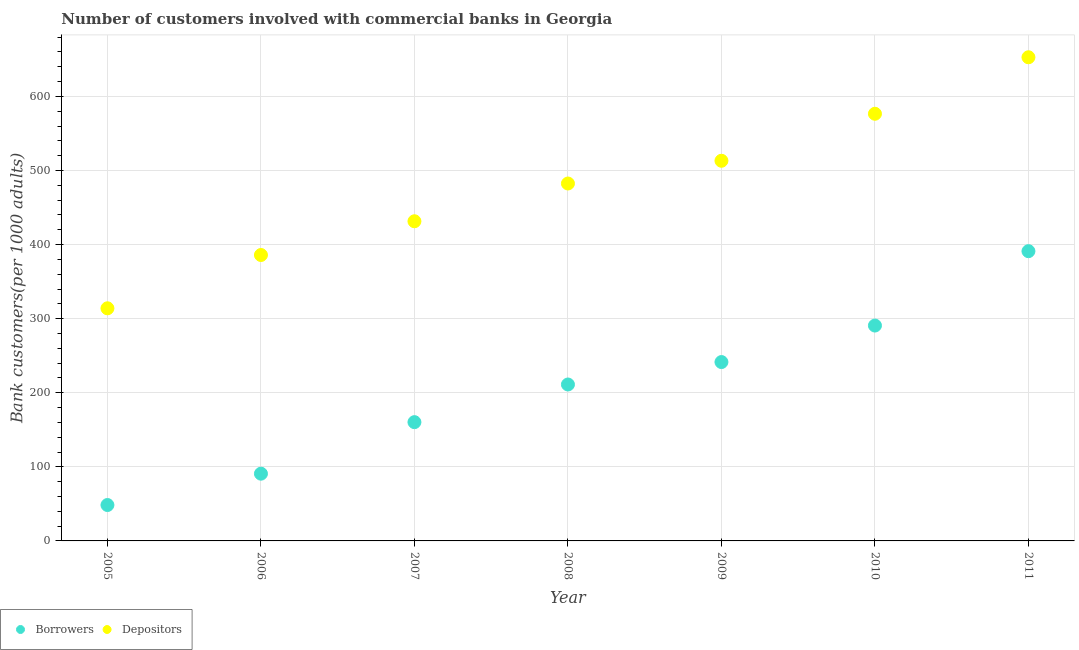How many different coloured dotlines are there?
Offer a terse response. 2. Is the number of dotlines equal to the number of legend labels?
Your answer should be compact. Yes. What is the number of borrowers in 2006?
Provide a succinct answer. 90.78. Across all years, what is the maximum number of borrowers?
Provide a succinct answer. 391.13. Across all years, what is the minimum number of borrowers?
Your answer should be very brief. 48.46. What is the total number of depositors in the graph?
Your answer should be compact. 3356.62. What is the difference between the number of depositors in 2006 and that in 2011?
Offer a terse response. -266.92. What is the difference between the number of borrowers in 2010 and the number of depositors in 2008?
Give a very brief answer. -191.75. What is the average number of borrowers per year?
Offer a very short reply. 204.86. In the year 2010, what is the difference between the number of borrowers and number of depositors?
Make the answer very short. -285.89. In how many years, is the number of borrowers greater than 520?
Make the answer very short. 0. What is the ratio of the number of borrowers in 2005 to that in 2007?
Make the answer very short. 0.3. Is the number of depositors in 2005 less than that in 2008?
Give a very brief answer. Yes. What is the difference between the highest and the second highest number of borrowers?
Keep it short and to the point. 100.4. What is the difference between the highest and the lowest number of borrowers?
Ensure brevity in your answer.  342.66. In how many years, is the number of borrowers greater than the average number of borrowers taken over all years?
Offer a very short reply. 4. Is the number of depositors strictly greater than the number of borrowers over the years?
Your answer should be compact. Yes. Is the number of depositors strictly less than the number of borrowers over the years?
Your response must be concise. No. What is the difference between two consecutive major ticks on the Y-axis?
Your response must be concise. 100. Does the graph contain any zero values?
Give a very brief answer. No. Does the graph contain grids?
Your answer should be very brief. Yes. Where does the legend appear in the graph?
Offer a terse response. Bottom left. What is the title of the graph?
Your answer should be very brief. Number of customers involved with commercial banks in Georgia. What is the label or title of the Y-axis?
Make the answer very short. Bank customers(per 1000 adults). What is the Bank customers(per 1000 adults) in Borrowers in 2005?
Your response must be concise. 48.46. What is the Bank customers(per 1000 adults) in Depositors in 2005?
Ensure brevity in your answer.  314.01. What is the Bank customers(per 1000 adults) of Borrowers in 2006?
Your response must be concise. 90.78. What is the Bank customers(per 1000 adults) of Depositors in 2006?
Offer a terse response. 385.96. What is the Bank customers(per 1000 adults) in Borrowers in 2007?
Ensure brevity in your answer.  160.33. What is the Bank customers(per 1000 adults) in Depositors in 2007?
Offer a very short reply. 431.51. What is the Bank customers(per 1000 adults) in Borrowers in 2008?
Make the answer very short. 211.16. What is the Bank customers(per 1000 adults) of Depositors in 2008?
Offer a terse response. 482.47. What is the Bank customers(per 1000 adults) of Borrowers in 2009?
Your answer should be very brief. 241.45. What is the Bank customers(per 1000 adults) of Depositors in 2009?
Keep it short and to the point. 513.17. What is the Bank customers(per 1000 adults) of Borrowers in 2010?
Your answer should be very brief. 290.72. What is the Bank customers(per 1000 adults) in Depositors in 2010?
Make the answer very short. 576.61. What is the Bank customers(per 1000 adults) of Borrowers in 2011?
Provide a short and direct response. 391.13. What is the Bank customers(per 1000 adults) of Depositors in 2011?
Provide a succinct answer. 652.89. Across all years, what is the maximum Bank customers(per 1000 adults) of Borrowers?
Provide a short and direct response. 391.13. Across all years, what is the maximum Bank customers(per 1000 adults) of Depositors?
Provide a succinct answer. 652.89. Across all years, what is the minimum Bank customers(per 1000 adults) of Borrowers?
Your response must be concise. 48.46. Across all years, what is the minimum Bank customers(per 1000 adults) of Depositors?
Provide a succinct answer. 314.01. What is the total Bank customers(per 1000 adults) of Borrowers in the graph?
Offer a very short reply. 1434.03. What is the total Bank customers(per 1000 adults) of Depositors in the graph?
Your answer should be compact. 3356.62. What is the difference between the Bank customers(per 1000 adults) in Borrowers in 2005 and that in 2006?
Give a very brief answer. -42.32. What is the difference between the Bank customers(per 1000 adults) in Depositors in 2005 and that in 2006?
Keep it short and to the point. -71.95. What is the difference between the Bank customers(per 1000 adults) in Borrowers in 2005 and that in 2007?
Your answer should be compact. -111.87. What is the difference between the Bank customers(per 1000 adults) in Depositors in 2005 and that in 2007?
Offer a terse response. -117.5. What is the difference between the Bank customers(per 1000 adults) in Borrowers in 2005 and that in 2008?
Your response must be concise. -162.7. What is the difference between the Bank customers(per 1000 adults) in Depositors in 2005 and that in 2008?
Offer a very short reply. -168.46. What is the difference between the Bank customers(per 1000 adults) of Borrowers in 2005 and that in 2009?
Offer a very short reply. -192.99. What is the difference between the Bank customers(per 1000 adults) in Depositors in 2005 and that in 2009?
Provide a short and direct response. -199.15. What is the difference between the Bank customers(per 1000 adults) in Borrowers in 2005 and that in 2010?
Your answer should be compact. -242.26. What is the difference between the Bank customers(per 1000 adults) of Depositors in 2005 and that in 2010?
Offer a terse response. -262.6. What is the difference between the Bank customers(per 1000 adults) in Borrowers in 2005 and that in 2011?
Provide a succinct answer. -342.67. What is the difference between the Bank customers(per 1000 adults) of Depositors in 2005 and that in 2011?
Provide a succinct answer. -338.87. What is the difference between the Bank customers(per 1000 adults) of Borrowers in 2006 and that in 2007?
Your response must be concise. -69.56. What is the difference between the Bank customers(per 1000 adults) in Depositors in 2006 and that in 2007?
Keep it short and to the point. -45.55. What is the difference between the Bank customers(per 1000 adults) in Borrowers in 2006 and that in 2008?
Give a very brief answer. -120.38. What is the difference between the Bank customers(per 1000 adults) in Depositors in 2006 and that in 2008?
Keep it short and to the point. -96.5. What is the difference between the Bank customers(per 1000 adults) in Borrowers in 2006 and that in 2009?
Your answer should be compact. -150.67. What is the difference between the Bank customers(per 1000 adults) of Depositors in 2006 and that in 2009?
Your answer should be compact. -127.2. What is the difference between the Bank customers(per 1000 adults) in Borrowers in 2006 and that in 2010?
Provide a short and direct response. -199.94. What is the difference between the Bank customers(per 1000 adults) in Depositors in 2006 and that in 2010?
Ensure brevity in your answer.  -190.64. What is the difference between the Bank customers(per 1000 adults) in Borrowers in 2006 and that in 2011?
Offer a terse response. -300.35. What is the difference between the Bank customers(per 1000 adults) of Depositors in 2006 and that in 2011?
Provide a succinct answer. -266.92. What is the difference between the Bank customers(per 1000 adults) of Borrowers in 2007 and that in 2008?
Keep it short and to the point. -50.83. What is the difference between the Bank customers(per 1000 adults) of Depositors in 2007 and that in 2008?
Your response must be concise. -50.96. What is the difference between the Bank customers(per 1000 adults) of Borrowers in 2007 and that in 2009?
Your answer should be very brief. -81.12. What is the difference between the Bank customers(per 1000 adults) in Depositors in 2007 and that in 2009?
Offer a very short reply. -81.65. What is the difference between the Bank customers(per 1000 adults) in Borrowers in 2007 and that in 2010?
Your answer should be very brief. -130.39. What is the difference between the Bank customers(per 1000 adults) of Depositors in 2007 and that in 2010?
Offer a very short reply. -145.1. What is the difference between the Bank customers(per 1000 adults) of Borrowers in 2007 and that in 2011?
Offer a terse response. -230.79. What is the difference between the Bank customers(per 1000 adults) of Depositors in 2007 and that in 2011?
Provide a short and direct response. -221.37. What is the difference between the Bank customers(per 1000 adults) in Borrowers in 2008 and that in 2009?
Your response must be concise. -30.29. What is the difference between the Bank customers(per 1000 adults) in Depositors in 2008 and that in 2009?
Provide a succinct answer. -30.7. What is the difference between the Bank customers(per 1000 adults) in Borrowers in 2008 and that in 2010?
Make the answer very short. -79.56. What is the difference between the Bank customers(per 1000 adults) of Depositors in 2008 and that in 2010?
Your answer should be compact. -94.14. What is the difference between the Bank customers(per 1000 adults) in Borrowers in 2008 and that in 2011?
Offer a very short reply. -179.97. What is the difference between the Bank customers(per 1000 adults) in Depositors in 2008 and that in 2011?
Offer a terse response. -170.42. What is the difference between the Bank customers(per 1000 adults) of Borrowers in 2009 and that in 2010?
Give a very brief answer. -49.27. What is the difference between the Bank customers(per 1000 adults) in Depositors in 2009 and that in 2010?
Provide a short and direct response. -63.44. What is the difference between the Bank customers(per 1000 adults) in Borrowers in 2009 and that in 2011?
Offer a very short reply. -149.68. What is the difference between the Bank customers(per 1000 adults) of Depositors in 2009 and that in 2011?
Give a very brief answer. -139.72. What is the difference between the Bank customers(per 1000 adults) of Borrowers in 2010 and that in 2011?
Give a very brief answer. -100.4. What is the difference between the Bank customers(per 1000 adults) of Depositors in 2010 and that in 2011?
Your answer should be very brief. -76.28. What is the difference between the Bank customers(per 1000 adults) in Borrowers in 2005 and the Bank customers(per 1000 adults) in Depositors in 2006?
Provide a succinct answer. -337.5. What is the difference between the Bank customers(per 1000 adults) in Borrowers in 2005 and the Bank customers(per 1000 adults) in Depositors in 2007?
Keep it short and to the point. -383.05. What is the difference between the Bank customers(per 1000 adults) of Borrowers in 2005 and the Bank customers(per 1000 adults) of Depositors in 2008?
Your response must be concise. -434.01. What is the difference between the Bank customers(per 1000 adults) of Borrowers in 2005 and the Bank customers(per 1000 adults) of Depositors in 2009?
Ensure brevity in your answer.  -464.7. What is the difference between the Bank customers(per 1000 adults) of Borrowers in 2005 and the Bank customers(per 1000 adults) of Depositors in 2010?
Ensure brevity in your answer.  -528.15. What is the difference between the Bank customers(per 1000 adults) of Borrowers in 2005 and the Bank customers(per 1000 adults) of Depositors in 2011?
Offer a terse response. -604.42. What is the difference between the Bank customers(per 1000 adults) in Borrowers in 2006 and the Bank customers(per 1000 adults) in Depositors in 2007?
Provide a short and direct response. -340.73. What is the difference between the Bank customers(per 1000 adults) of Borrowers in 2006 and the Bank customers(per 1000 adults) of Depositors in 2008?
Give a very brief answer. -391.69. What is the difference between the Bank customers(per 1000 adults) of Borrowers in 2006 and the Bank customers(per 1000 adults) of Depositors in 2009?
Provide a succinct answer. -422.39. What is the difference between the Bank customers(per 1000 adults) of Borrowers in 2006 and the Bank customers(per 1000 adults) of Depositors in 2010?
Keep it short and to the point. -485.83. What is the difference between the Bank customers(per 1000 adults) in Borrowers in 2006 and the Bank customers(per 1000 adults) in Depositors in 2011?
Ensure brevity in your answer.  -562.11. What is the difference between the Bank customers(per 1000 adults) in Borrowers in 2007 and the Bank customers(per 1000 adults) in Depositors in 2008?
Ensure brevity in your answer.  -322.14. What is the difference between the Bank customers(per 1000 adults) of Borrowers in 2007 and the Bank customers(per 1000 adults) of Depositors in 2009?
Keep it short and to the point. -352.83. What is the difference between the Bank customers(per 1000 adults) of Borrowers in 2007 and the Bank customers(per 1000 adults) of Depositors in 2010?
Give a very brief answer. -416.28. What is the difference between the Bank customers(per 1000 adults) in Borrowers in 2007 and the Bank customers(per 1000 adults) in Depositors in 2011?
Keep it short and to the point. -492.55. What is the difference between the Bank customers(per 1000 adults) in Borrowers in 2008 and the Bank customers(per 1000 adults) in Depositors in 2009?
Your response must be concise. -302.01. What is the difference between the Bank customers(per 1000 adults) of Borrowers in 2008 and the Bank customers(per 1000 adults) of Depositors in 2010?
Give a very brief answer. -365.45. What is the difference between the Bank customers(per 1000 adults) in Borrowers in 2008 and the Bank customers(per 1000 adults) in Depositors in 2011?
Offer a very short reply. -441.73. What is the difference between the Bank customers(per 1000 adults) in Borrowers in 2009 and the Bank customers(per 1000 adults) in Depositors in 2010?
Provide a short and direct response. -335.16. What is the difference between the Bank customers(per 1000 adults) in Borrowers in 2009 and the Bank customers(per 1000 adults) in Depositors in 2011?
Offer a very short reply. -411.43. What is the difference between the Bank customers(per 1000 adults) of Borrowers in 2010 and the Bank customers(per 1000 adults) of Depositors in 2011?
Ensure brevity in your answer.  -362.16. What is the average Bank customers(per 1000 adults) in Borrowers per year?
Offer a terse response. 204.86. What is the average Bank customers(per 1000 adults) in Depositors per year?
Make the answer very short. 479.52. In the year 2005, what is the difference between the Bank customers(per 1000 adults) in Borrowers and Bank customers(per 1000 adults) in Depositors?
Make the answer very short. -265.55. In the year 2006, what is the difference between the Bank customers(per 1000 adults) in Borrowers and Bank customers(per 1000 adults) in Depositors?
Provide a short and direct response. -295.19. In the year 2007, what is the difference between the Bank customers(per 1000 adults) of Borrowers and Bank customers(per 1000 adults) of Depositors?
Offer a very short reply. -271.18. In the year 2008, what is the difference between the Bank customers(per 1000 adults) in Borrowers and Bank customers(per 1000 adults) in Depositors?
Your answer should be compact. -271.31. In the year 2009, what is the difference between the Bank customers(per 1000 adults) of Borrowers and Bank customers(per 1000 adults) of Depositors?
Provide a short and direct response. -271.71. In the year 2010, what is the difference between the Bank customers(per 1000 adults) of Borrowers and Bank customers(per 1000 adults) of Depositors?
Ensure brevity in your answer.  -285.89. In the year 2011, what is the difference between the Bank customers(per 1000 adults) of Borrowers and Bank customers(per 1000 adults) of Depositors?
Provide a short and direct response. -261.76. What is the ratio of the Bank customers(per 1000 adults) of Borrowers in 2005 to that in 2006?
Keep it short and to the point. 0.53. What is the ratio of the Bank customers(per 1000 adults) in Depositors in 2005 to that in 2006?
Offer a very short reply. 0.81. What is the ratio of the Bank customers(per 1000 adults) of Borrowers in 2005 to that in 2007?
Your response must be concise. 0.3. What is the ratio of the Bank customers(per 1000 adults) of Depositors in 2005 to that in 2007?
Offer a very short reply. 0.73. What is the ratio of the Bank customers(per 1000 adults) in Borrowers in 2005 to that in 2008?
Give a very brief answer. 0.23. What is the ratio of the Bank customers(per 1000 adults) of Depositors in 2005 to that in 2008?
Your response must be concise. 0.65. What is the ratio of the Bank customers(per 1000 adults) in Borrowers in 2005 to that in 2009?
Provide a short and direct response. 0.2. What is the ratio of the Bank customers(per 1000 adults) in Depositors in 2005 to that in 2009?
Make the answer very short. 0.61. What is the ratio of the Bank customers(per 1000 adults) of Depositors in 2005 to that in 2010?
Your answer should be very brief. 0.54. What is the ratio of the Bank customers(per 1000 adults) in Borrowers in 2005 to that in 2011?
Keep it short and to the point. 0.12. What is the ratio of the Bank customers(per 1000 adults) in Depositors in 2005 to that in 2011?
Provide a succinct answer. 0.48. What is the ratio of the Bank customers(per 1000 adults) of Borrowers in 2006 to that in 2007?
Your answer should be very brief. 0.57. What is the ratio of the Bank customers(per 1000 adults) in Depositors in 2006 to that in 2007?
Keep it short and to the point. 0.89. What is the ratio of the Bank customers(per 1000 adults) in Borrowers in 2006 to that in 2008?
Your answer should be compact. 0.43. What is the ratio of the Bank customers(per 1000 adults) of Depositors in 2006 to that in 2008?
Provide a short and direct response. 0.8. What is the ratio of the Bank customers(per 1000 adults) in Borrowers in 2006 to that in 2009?
Your answer should be very brief. 0.38. What is the ratio of the Bank customers(per 1000 adults) in Depositors in 2006 to that in 2009?
Your response must be concise. 0.75. What is the ratio of the Bank customers(per 1000 adults) in Borrowers in 2006 to that in 2010?
Offer a very short reply. 0.31. What is the ratio of the Bank customers(per 1000 adults) of Depositors in 2006 to that in 2010?
Your answer should be very brief. 0.67. What is the ratio of the Bank customers(per 1000 adults) in Borrowers in 2006 to that in 2011?
Ensure brevity in your answer.  0.23. What is the ratio of the Bank customers(per 1000 adults) of Depositors in 2006 to that in 2011?
Your response must be concise. 0.59. What is the ratio of the Bank customers(per 1000 adults) in Borrowers in 2007 to that in 2008?
Make the answer very short. 0.76. What is the ratio of the Bank customers(per 1000 adults) of Depositors in 2007 to that in 2008?
Offer a terse response. 0.89. What is the ratio of the Bank customers(per 1000 adults) of Borrowers in 2007 to that in 2009?
Provide a succinct answer. 0.66. What is the ratio of the Bank customers(per 1000 adults) in Depositors in 2007 to that in 2009?
Ensure brevity in your answer.  0.84. What is the ratio of the Bank customers(per 1000 adults) of Borrowers in 2007 to that in 2010?
Offer a very short reply. 0.55. What is the ratio of the Bank customers(per 1000 adults) of Depositors in 2007 to that in 2010?
Make the answer very short. 0.75. What is the ratio of the Bank customers(per 1000 adults) of Borrowers in 2007 to that in 2011?
Provide a short and direct response. 0.41. What is the ratio of the Bank customers(per 1000 adults) of Depositors in 2007 to that in 2011?
Your answer should be very brief. 0.66. What is the ratio of the Bank customers(per 1000 adults) in Borrowers in 2008 to that in 2009?
Offer a terse response. 0.87. What is the ratio of the Bank customers(per 1000 adults) of Depositors in 2008 to that in 2009?
Provide a succinct answer. 0.94. What is the ratio of the Bank customers(per 1000 adults) in Borrowers in 2008 to that in 2010?
Provide a succinct answer. 0.73. What is the ratio of the Bank customers(per 1000 adults) in Depositors in 2008 to that in 2010?
Your response must be concise. 0.84. What is the ratio of the Bank customers(per 1000 adults) of Borrowers in 2008 to that in 2011?
Provide a short and direct response. 0.54. What is the ratio of the Bank customers(per 1000 adults) of Depositors in 2008 to that in 2011?
Make the answer very short. 0.74. What is the ratio of the Bank customers(per 1000 adults) of Borrowers in 2009 to that in 2010?
Provide a short and direct response. 0.83. What is the ratio of the Bank customers(per 1000 adults) in Depositors in 2009 to that in 2010?
Offer a very short reply. 0.89. What is the ratio of the Bank customers(per 1000 adults) in Borrowers in 2009 to that in 2011?
Ensure brevity in your answer.  0.62. What is the ratio of the Bank customers(per 1000 adults) of Depositors in 2009 to that in 2011?
Provide a succinct answer. 0.79. What is the ratio of the Bank customers(per 1000 adults) in Borrowers in 2010 to that in 2011?
Give a very brief answer. 0.74. What is the ratio of the Bank customers(per 1000 adults) in Depositors in 2010 to that in 2011?
Your answer should be compact. 0.88. What is the difference between the highest and the second highest Bank customers(per 1000 adults) of Borrowers?
Keep it short and to the point. 100.4. What is the difference between the highest and the second highest Bank customers(per 1000 adults) in Depositors?
Provide a short and direct response. 76.28. What is the difference between the highest and the lowest Bank customers(per 1000 adults) of Borrowers?
Make the answer very short. 342.67. What is the difference between the highest and the lowest Bank customers(per 1000 adults) of Depositors?
Offer a terse response. 338.87. 